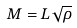<formula> <loc_0><loc_0><loc_500><loc_500>M = L \sqrt { \rho }</formula> 